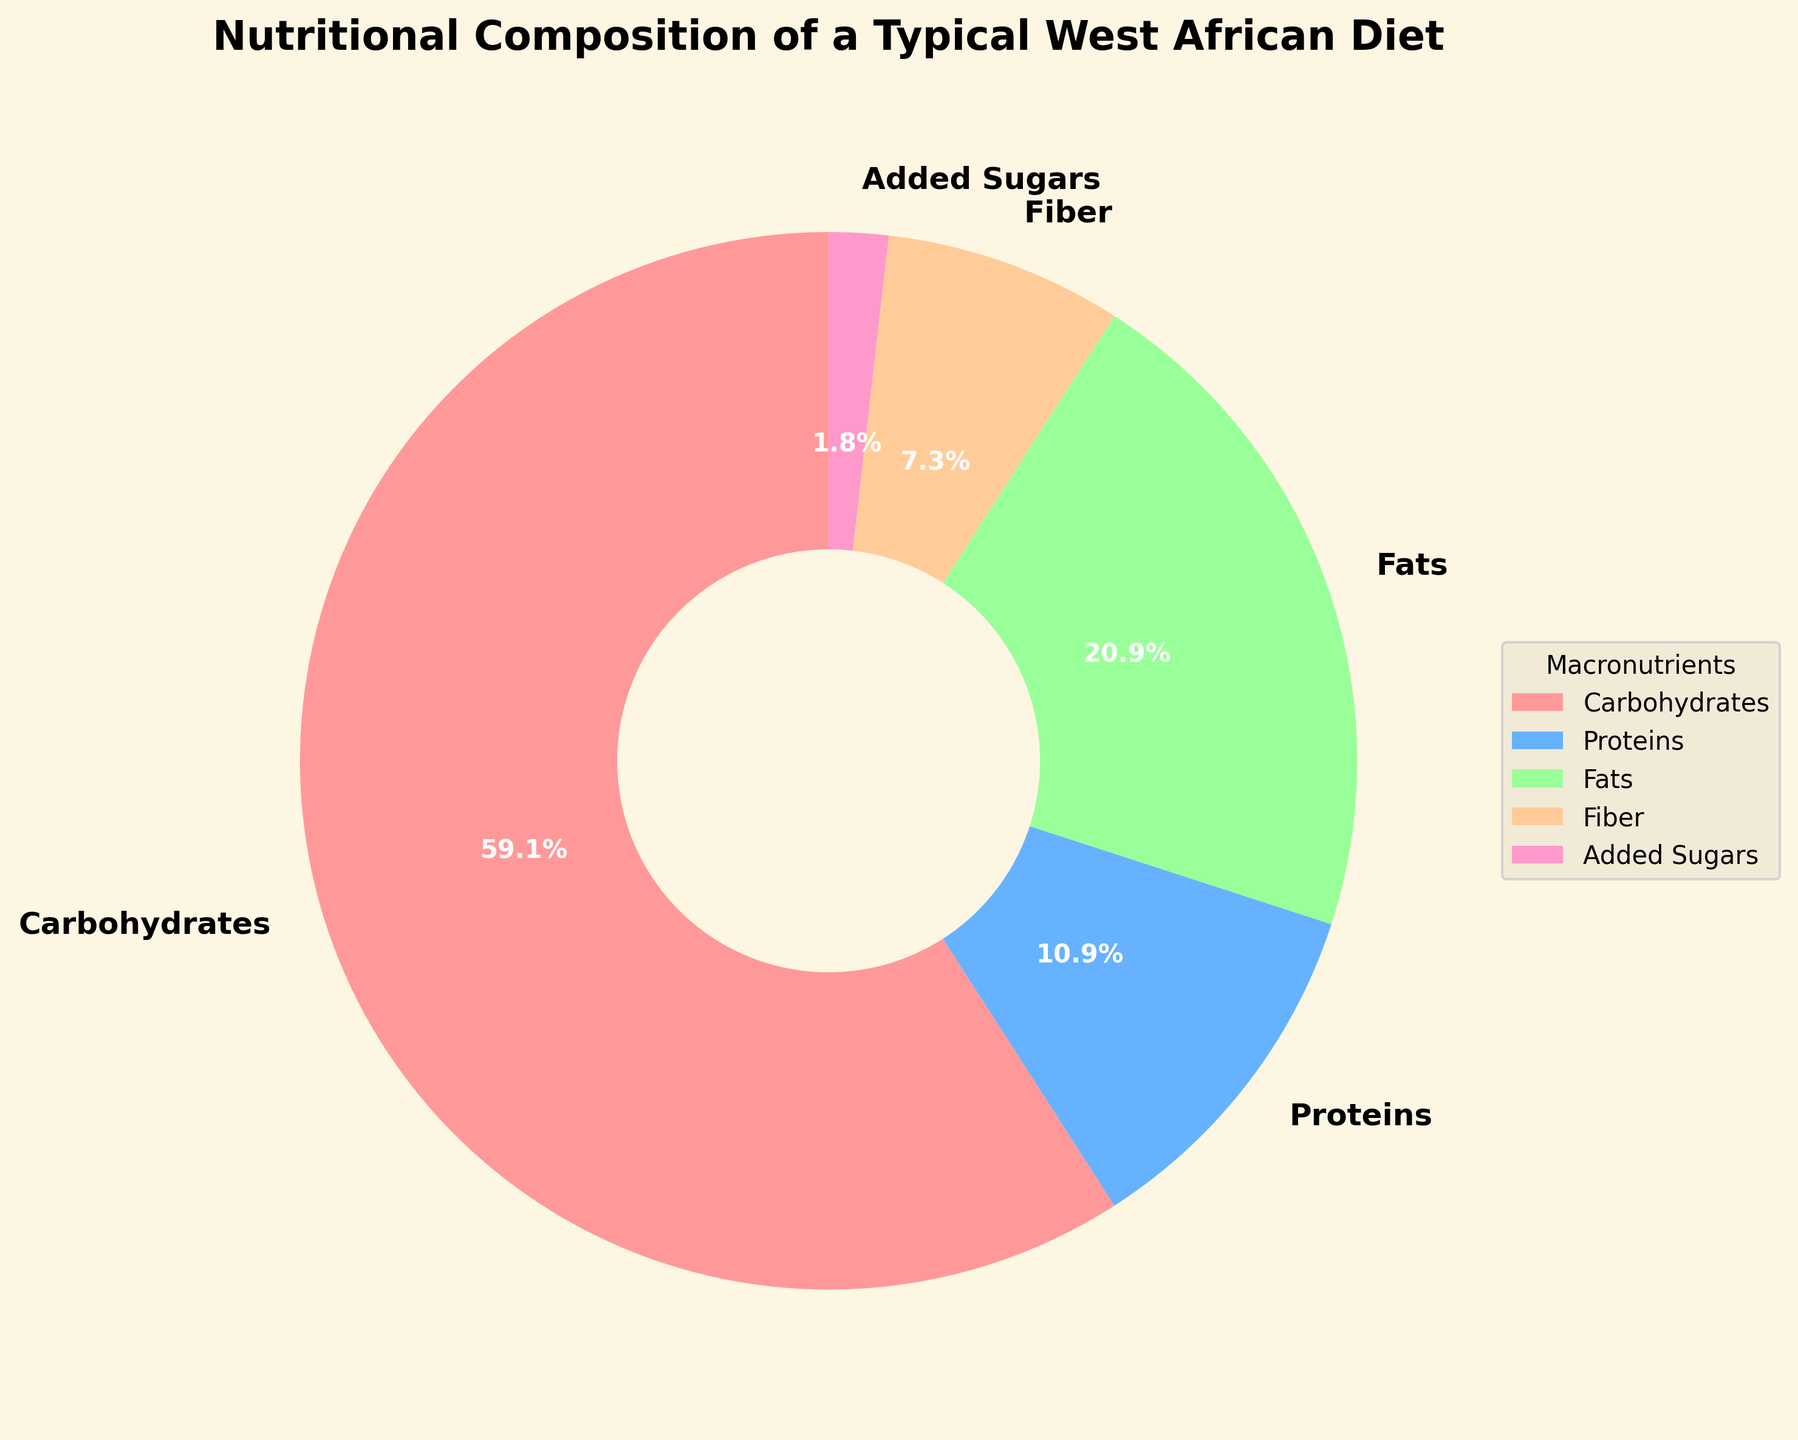What's the percentage of carbohydrates in the diet? The pie chart shows the proportion of various macronutrients in a typical West African diet. Look for the segment labeled "Carbohydrates" to find the corresponding percentage value.
Answer: 65% Which macronutrient has the lowest percentage in the diet? Examine the segments of the pie chart for the smallest slice. The label associated with the smallest segment will indicate the macronutrient with the lowest percentage.
Answer: Added Sugars What is the combined percentage of fibers and added sugars? Locate the segments labeled "Fiber" and "Added Sugars" on the pie chart. Sum up their respective percentage values: 8% (Fiber) + 2% (Added Sugars) = 10%.
Answer: 10% Is the percentage of fats greater than that of proteins? Compare the sizes of the segments labeled "Fats" and "Proteins" in the pie chart. The "Fats" segment is larger, indicating a higher percentage.
Answer: Yes How does the percentage of proteins compare to the percentage of fibers? Look at the segments labeled "Proteins" and "Fiber." Notice that the percentage for "Proteins" (12%) is higher than that for "Fiber" (8%).
Answer: Proteins have a higher percentage than fibers What are the total percentages of carbohydrates, proteins, and fats combined? Sum the percentages of the segments labeled "Carbohydrates," "Proteins," and "Fats": 65% (Carbohydrates) + 12% (Proteins) + 23% (Fats) = 100%.
Answer: 100% How much higher is the percentage of carbohydrates compared to fats? Subtract the percentage of "Fats" from "Carbohydrates": 65% (Carbohydrates) - 23% (Fats) = 42%.
Answer: 42% Describe the color and size of the segment representing fiber. Look for the segment labeled "Fiber" in the pie chart. It is visually distinct with a specific size and color. The fiber segment is smaller and has a distinctive color that stands out.
Answer: Smaller segment, distinct color 